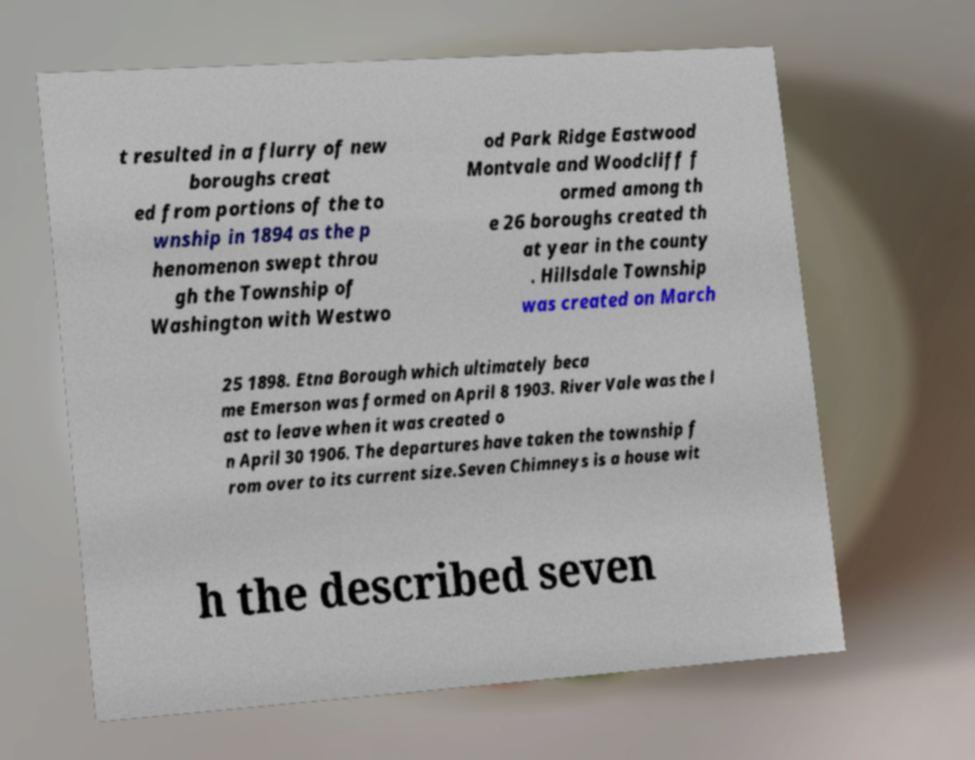Could you extract and type out the text from this image? t resulted in a flurry of new boroughs creat ed from portions of the to wnship in 1894 as the p henomenon swept throu gh the Township of Washington with Westwo od Park Ridge Eastwood Montvale and Woodcliff f ormed among th e 26 boroughs created th at year in the county . Hillsdale Township was created on March 25 1898. Etna Borough which ultimately beca me Emerson was formed on April 8 1903. River Vale was the l ast to leave when it was created o n April 30 1906. The departures have taken the township f rom over to its current size.Seven Chimneys is a house wit h the described seven 